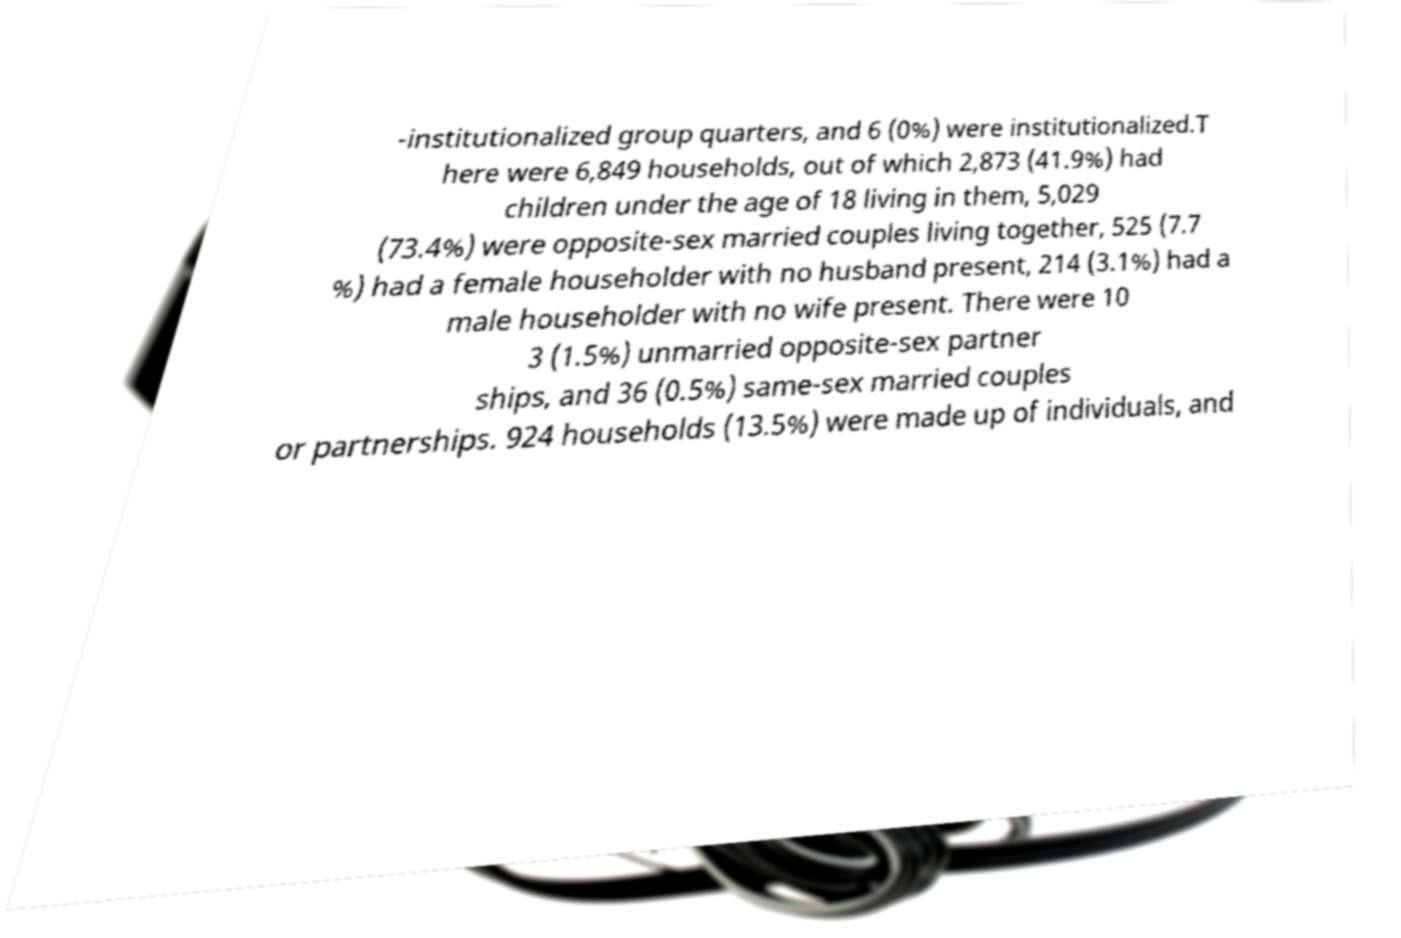Could you extract and type out the text from this image? -institutionalized group quarters, and 6 (0%) were institutionalized.T here were 6,849 households, out of which 2,873 (41.9%) had children under the age of 18 living in them, 5,029 (73.4%) were opposite-sex married couples living together, 525 (7.7 %) had a female householder with no husband present, 214 (3.1%) had a male householder with no wife present. There were 10 3 (1.5%) unmarried opposite-sex partner ships, and 36 (0.5%) same-sex married couples or partnerships. 924 households (13.5%) were made up of individuals, and 